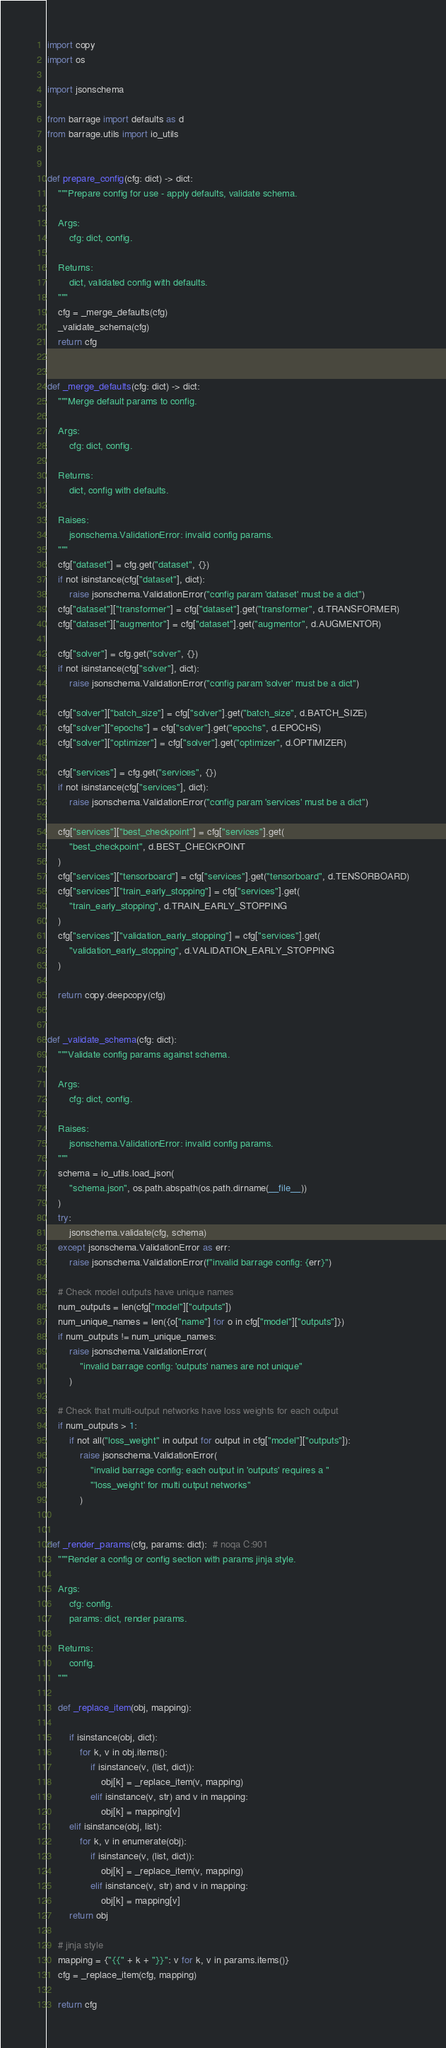<code> <loc_0><loc_0><loc_500><loc_500><_Python_>import copy
import os

import jsonschema

from barrage import defaults as d
from barrage.utils import io_utils


def prepare_config(cfg: dict) -> dict:
    """Prepare config for use - apply defaults, validate schema.

    Args:
        cfg: dict, config.

    Returns:
        dict, validated config with defaults.
    """
    cfg = _merge_defaults(cfg)
    _validate_schema(cfg)
    return cfg


def _merge_defaults(cfg: dict) -> dict:
    """Merge default params to config.

    Args:
        cfg: dict, config.

    Returns:
        dict, config with defaults.

    Raises:
        jsonschema.ValidationError: invalid config params.
    """
    cfg["dataset"] = cfg.get("dataset", {})
    if not isinstance(cfg["dataset"], dict):
        raise jsonschema.ValidationError("config param 'dataset' must be a dict")
    cfg["dataset"]["transformer"] = cfg["dataset"].get("transformer", d.TRANSFORMER)
    cfg["dataset"]["augmentor"] = cfg["dataset"].get("augmentor", d.AUGMENTOR)

    cfg["solver"] = cfg.get("solver", {})
    if not isinstance(cfg["solver"], dict):
        raise jsonschema.ValidationError("config param 'solver' must be a dict")

    cfg["solver"]["batch_size"] = cfg["solver"].get("batch_size", d.BATCH_SIZE)
    cfg["solver"]["epochs"] = cfg["solver"].get("epochs", d.EPOCHS)
    cfg["solver"]["optimizer"] = cfg["solver"].get("optimizer", d.OPTIMIZER)

    cfg["services"] = cfg.get("services", {})
    if not isinstance(cfg["services"], dict):
        raise jsonschema.ValidationError("config param 'services' must be a dict")

    cfg["services"]["best_checkpoint"] = cfg["services"].get(
        "best_checkpoint", d.BEST_CHECKPOINT
    )
    cfg["services"]["tensorboard"] = cfg["services"].get("tensorboard", d.TENSORBOARD)
    cfg["services"]["train_early_stopping"] = cfg["services"].get(
        "train_early_stopping", d.TRAIN_EARLY_STOPPING
    )
    cfg["services"]["validation_early_stopping"] = cfg["services"].get(
        "validation_early_stopping", d.VALIDATION_EARLY_STOPPING
    )

    return copy.deepcopy(cfg)


def _validate_schema(cfg: dict):
    """Validate config params against schema.

    Args:
        cfg: dict, config.

    Raises:
        jsonschema.ValidationError: invalid config params.
    """
    schema = io_utils.load_json(
        "schema.json", os.path.abspath(os.path.dirname(__file__))
    )
    try:
        jsonschema.validate(cfg, schema)
    except jsonschema.ValidationError as err:
        raise jsonschema.ValidationError(f"invalid barrage config: {err}")

    # Check model outputs have unique names
    num_outputs = len(cfg["model"]["outputs"])
    num_unique_names = len({o["name"] for o in cfg["model"]["outputs"]})
    if num_outputs != num_unique_names:
        raise jsonschema.ValidationError(
            "invalid barrage config: 'outputs' names are not unique"
        )

    # Check that multi-output networks have loss weights for each output
    if num_outputs > 1:
        if not all("loss_weight" in output for output in cfg["model"]["outputs"]):
            raise jsonschema.ValidationError(
                "invalid barrage config: each output in 'outputs' requires a "
                "'loss_weight' for multi output networks"
            )


def _render_params(cfg, params: dict):  # noqa C:901
    """Render a config or config section with params jinja style.

    Args:
        cfg: config.
        params: dict, render params.

    Returns:
        config.
    """

    def _replace_item(obj, mapping):

        if isinstance(obj, dict):
            for k, v in obj.items():
                if isinstance(v, (list, dict)):
                    obj[k] = _replace_item(v, mapping)
                elif isinstance(v, str) and v in mapping:
                    obj[k] = mapping[v]
        elif isinstance(obj, list):
            for k, v in enumerate(obj):
                if isinstance(v, (list, dict)):
                    obj[k] = _replace_item(v, mapping)
                elif isinstance(v, str) and v in mapping:
                    obj[k] = mapping[v]
        return obj

    # jinja style
    mapping = {"{{" + k + "}}": v for k, v in params.items()}
    cfg = _replace_item(cfg, mapping)

    return cfg
</code> 